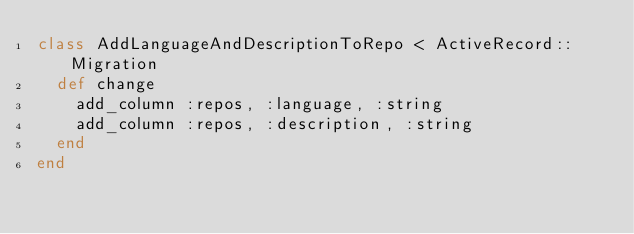Convert code to text. <code><loc_0><loc_0><loc_500><loc_500><_Ruby_>class AddLanguageAndDescriptionToRepo < ActiveRecord::Migration
  def change
    add_column :repos, :language, :string
    add_column :repos, :description, :string
  end
end
</code> 